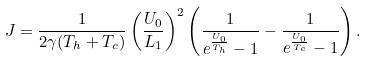Convert formula to latex. <formula><loc_0><loc_0><loc_500><loc_500>J = \frac { 1 } { 2 \gamma ( T _ { h } + T _ { c } ) } \left ( \frac { U _ { 0 } } { L _ { 1 } } \right ) ^ { 2 } \left ( \frac { 1 } { e ^ { \frac { U _ { 0 } } { T _ { h } } } - 1 } - \frac { 1 } { e ^ { \frac { U _ { 0 } } { T _ { c } } } - 1 } \right ) .</formula> 